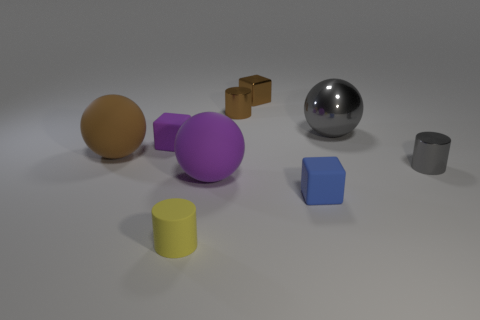Add 1 cylinders. How many objects exist? 10 Subtract all cubes. How many objects are left? 6 Add 4 large cyan rubber balls. How many large cyan rubber balls exist? 4 Subtract 0 green cubes. How many objects are left? 9 Subtract all blue matte cylinders. Subtract all tiny brown cylinders. How many objects are left? 8 Add 3 large things. How many large things are left? 6 